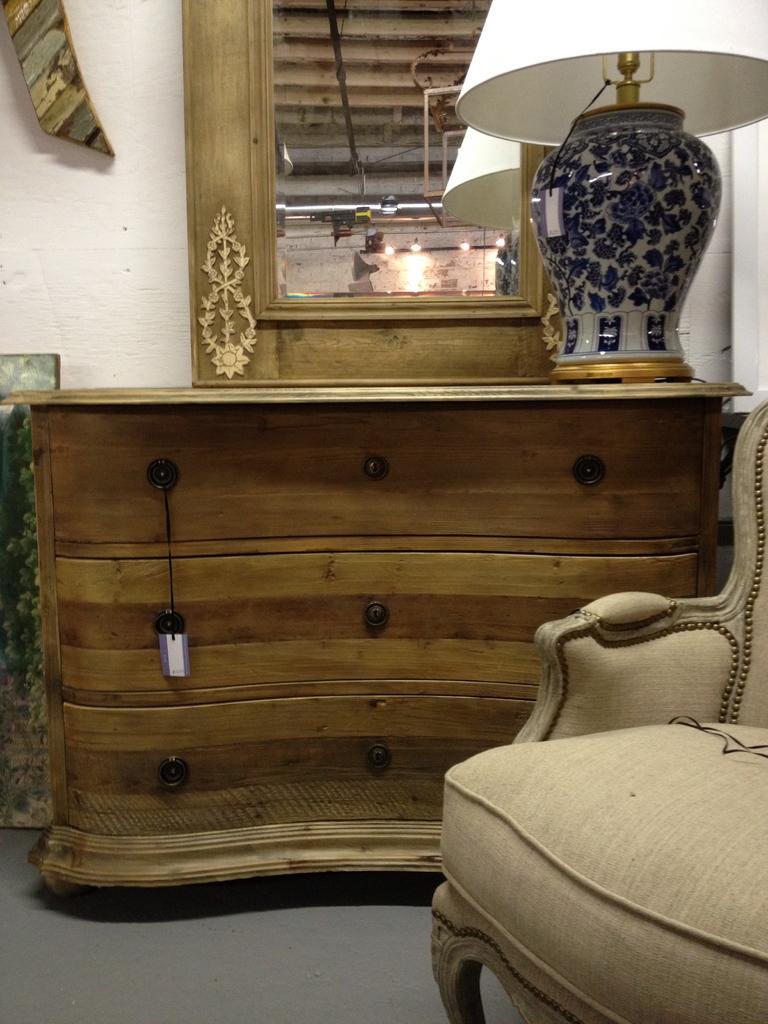How would you summarize this image in a sentence or two? In this room there is a dressing table and a desks. Here is a lamp. And we can observe sofa here. 